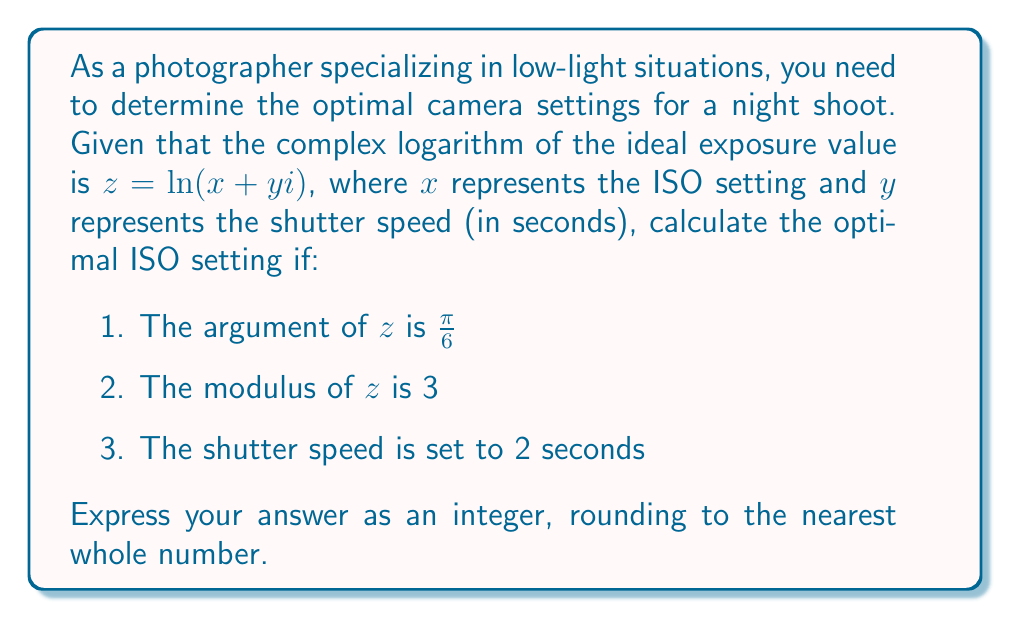Teach me how to tackle this problem. Let's approach this step-by-step:

1) We know that for a complex number $z = a + bi$, its polar form is $z = r(\cos\theta + i\sin\theta)$, where $r$ is the modulus and $\theta$ is the argument.

2) Given information:
   - Argument of $z$ = $\frac{\pi}{6}$
   - Modulus of $z$ = 3
   - Shutter speed ($y$) = 2 seconds

3) Using Euler's formula, we can express $z$ as:

   $$z = 3(\cos\frac{\pi}{6} + i\sin\frac{\pi}{6})$$

4) Expanding this:

   $$z = 3(\frac{\sqrt{3}}{2} + i\frac{1}{2})$$

5) Therefore:

   $$z = \frac{3\sqrt{3}}{2} + \frac{3i}{2}$$

6) Recall that $z = \ln(x + yi)$. This means:

   $$\frac{3\sqrt{3}}{2} + \frac{3i}{2} = \ln(x + 2i)$$

7) Using the properties of complex logarithms:

   $$\ln(x + 2i) = \ln\sqrt{x^2 + 4} + i\arctan(\frac{2}{x})$$

8) Equating real and imaginary parts:

   $$\frac{3\sqrt{3}}{2} = \ln\sqrt{x^2 + 4}$$
   $$\frac{3}{2} = \arctan(\frac{2}{x})$$

9) From the second equation:

   $$\tan\frac{3}{2} = \frac{2}{x}$$
   $$x = \frac{2}{\tan\frac{3}{2}} \approx 0.727$$

10) From the first equation:

    $$e^{\frac{3\sqrt{3}}{2}} = \sqrt{x^2 + 4}$$
    $$e^{3\sqrt{3}} = x^2 + 4$$
    $$x^2 = e^{3\sqrt{3}} - 4 \approx 1603.895$$
    $$x \approx 40.05$$

11) The second solution (40.05) is the correct one as it satisfies both equations.

Therefore, the optimal ISO setting is approximately 40, rounded to the nearest whole number.
Answer: 40 